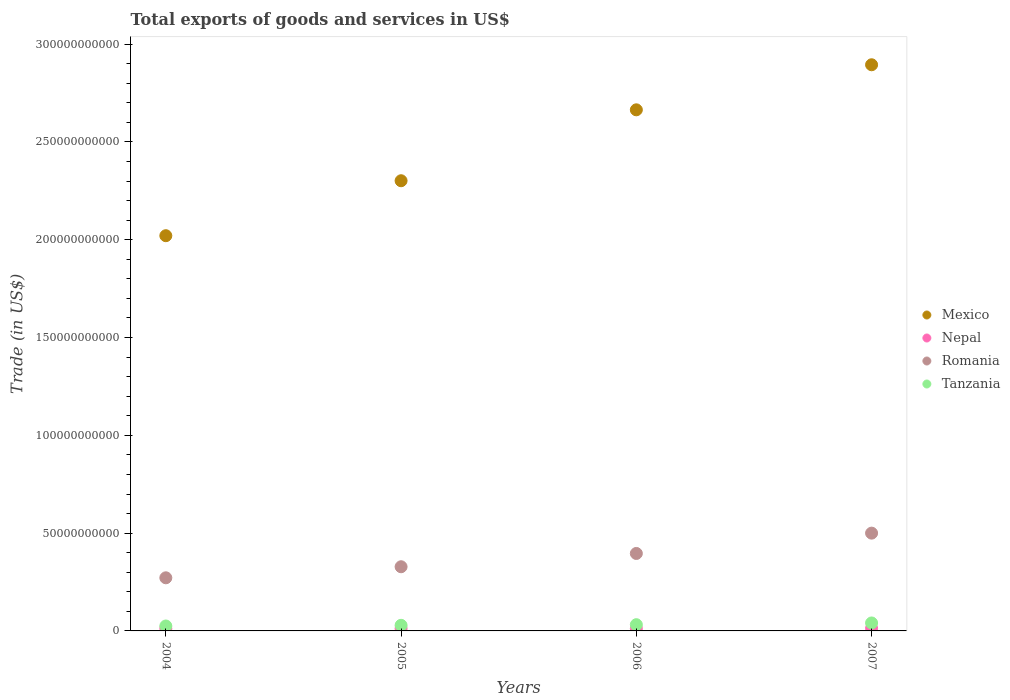How many different coloured dotlines are there?
Make the answer very short. 4. What is the total exports of goods and services in Mexico in 2004?
Your response must be concise. 2.02e+11. Across all years, what is the maximum total exports of goods and services in Tanzania?
Ensure brevity in your answer.  4.07e+09. Across all years, what is the minimum total exports of goods and services in Romania?
Offer a terse response. 2.72e+1. In which year was the total exports of goods and services in Nepal maximum?
Your response must be concise. 2007. In which year was the total exports of goods and services in Romania minimum?
Give a very brief answer. 2004. What is the total total exports of goods and services in Mexico in the graph?
Your answer should be very brief. 9.88e+11. What is the difference between the total exports of goods and services in Nepal in 2004 and that in 2005?
Your answer should be very brief. 2.78e+07. What is the difference between the total exports of goods and services in Nepal in 2006 and the total exports of goods and services in Romania in 2005?
Keep it short and to the point. -3.16e+1. What is the average total exports of goods and services in Nepal per year?
Provide a short and direct response. 1.24e+09. In the year 2006, what is the difference between the total exports of goods and services in Romania and total exports of goods and services in Nepal?
Provide a short and direct response. 3.84e+1. What is the ratio of the total exports of goods and services in Nepal in 2005 to that in 2007?
Give a very brief answer. 0.89. Is the total exports of goods and services in Mexico in 2005 less than that in 2006?
Make the answer very short. Yes. Is the difference between the total exports of goods and services in Romania in 2006 and 2007 greater than the difference between the total exports of goods and services in Nepal in 2006 and 2007?
Your answer should be very brief. No. What is the difference between the highest and the second highest total exports of goods and services in Mexico?
Offer a terse response. 2.30e+1. What is the difference between the highest and the lowest total exports of goods and services in Nepal?
Provide a succinct answer. 1.42e+08. Is the sum of the total exports of goods and services in Nepal in 2004 and 2007 greater than the maximum total exports of goods and services in Tanzania across all years?
Provide a short and direct response. No. Is it the case that in every year, the sum of the total exports of goods and services in Mexico and total exports of goods and services in Romania  is greater than the sum of total exports of goods and services in Nepal and total exports of goods and services in Tanzania?
Offer a terse response. Yes. Is the total exports of goods and services in Mexico strictly greater than the total exports of goods and services in Nepal over the years?
Ensure brevity in your answer.  Yes. Is the total exports of goods and services in Nepal strictly less than the total exports of goods and services in Tanzania over the years?
Provide a succinct answer. Yes. How many dotlines are there?
Keep it short and to the point. 4. Does the graph contain grids?
Your response must be concise. No. What is the title of the graph?
Offer a very short reply. Total exports of goods and services in US$. Does "Brazil" appear as one of the legend labels in the graph?
Your answer should be very brief. No. What is the label or title of the X-axis?
Keep it short and to the point. Years. What is the label or title of the Y-axis?
Offer a very short reply. Trade (in US$). What is the Trade (in US$) in Mexico in 2004?
Ensure brevity in your answer.  2.02e+11. What is the Trade (in US$) of Nepal in 2004?
Offer a very short reply. 1.21e+09. What is the Trade (in US$) of Romania in 2004?
Give a very brief answer. 2.72e+1. What is the Trade (in US$) in Tanzania in 2004?
Your answer should be compact. 2.52e+09. What is the Trade (in US$) of Mexico in 2005?
Make the answer very short. 2.30e+11. What is the Trade (in US$) in Nepal in 2005?
Ensure brevity in your answer.  1.19e+09. What is the Trade (in US$) of Romania in 2005?
Your response must be concise. 3.28e+1. What is the Trade (in US$) of Tanzania in 2005?
Offer a terse response. 2.86e+09. What is the Trade (in US$) in Mexico in 2006?
Your response must be concise. 2.66e+11. What is the Trade (in US$) in Nepal in 2006?
Your answer should be very brief. 1.22e+09. What is the Trade (in US$) in Romania in 2006?
Your answer should be compact. 3.96e+1. What is the Trade (in US$) in Tanzania in 2006?
Your response must be concise. 3.18e+09. What is the Trade (in US$) of Mexico in 2007?
Your answer should be very brief. 2.89e+11. What is the Trade (in US$) of Nepal in 2007?
Make the answer very short. 1.33e+09. What is the Trade (in US$) of Romania in 2007?
Give a very brief answer. 5.00e+1. What is the Trade (in US$) in Tanzania in 2007?
Offer a terse response. 4.07e+09. Across all years, what is the maximum Trade (in US$) in Mexico?
Provide a succinct answer. 2.89e+11. Across all years, what is the maximum Trade (in US$) of Nepal?
Provide a succinct answer. 1.33e+09. Across all years, what is the maximum Trade (in US$) in Romania?
Make the answer very short. 5.00e+1. Across all years, what is the maximum Trade (in US$) in Tanzania?
Give a very brief answer. 4.07e+09. Across all years, what is the minimum Trade (in US$) in Mexico?
Provide a succinct answer. 2.02e+11. Across all years, what is the minimum Trade (in US$) in Nepal?
Provide a succinct answer. 1.19e+09. Across all years, what is the minimum Trade (in US$) of Romania?
Your answer should be compact. 2.72e+1. Across all years, what is the minimum Trade (in US$) of Tanzania?
Your answer should be very brief. 2.52e+09. What is the total Trade (in US$) in Mexico in the graph?
Provide a succinct answer. 9.88e+11. What is the total Trade (in US$) in Nepal in the graph?
Provide a short and direct response. 4.94e+09. What is the total Trade (in US$) of Romania in the graph?
Offer a very short reply. 1.50e+11. What is the total Trade (in US$) in Tanzania in the graph?
Provide a succinct answer. 1.26e+1. What is the difference between the Trade (in US$) of Mexico in 2004 and that in 2005?
Give a very brief answer. -2.81e+1. What is the difference between the Trade (in US$) of Nepal in 2004 and that in 2005?
Offer a terse response. 2.78e+07. What is the difference between the Trade (in US$) of Romania in 2004 and that in 2005?
Offer a very short reply. -5.65e+09. What is the difference between the Trade (in US$) in Tanzania in 2004 and that in 2005?
Offer a terse response. -3.43e+08. What is the difference between the Trade (in US$) in Mexico in 2004 and that in 2006?
Offer a terse response. -6.44e+1. What is the difference between the Trade (in US$) of Nepal in 2004 and that in 2006?
Your answer should be very brief. -2.58e+06. What is the difference between the Trade (in US$) of Romania in 2004 and that in 2006?
Give a very brief answer. -1.24e+1. What is the difference between the Trade (in US$) of Tanzania in 2004 and that in 2006?
Provide a succinct answer. -6.62e+08. What is the difference between the Trade (in US$) of Mexico in 2004 and that in 2007?
Make the answer very short. -8.74e+1. What is the difference between the Trade (in US$) of Nepal in 2004 and that in 2007?
Your response must be concise. -1.14e+08. What is the difference between the Trade (in US$) in Romania in 2004 and that in 2007?
Your answer should be very brief. -2.28e+1. What is the difference between the Trade (in US$) of Tanzania in 2004 and that in 2007?
Your answer should be very brief. -1.55e+09. What is the difference between the Trade (in US$) of Mexico in 2005 and that in 2006?
Keep it short and to the point. -3.63e+1. What is the difference between the Trade (in US$) of Nepal in 2005 and that in 2006?
Make the answer very short. -3.04e+07. What is the difference between the Trade (in US$) of Romania in 2005 and that in 2006?
Your answer should be compact. -6.80e+09. What is the difference between the Trade (in US$) of Tanzania in 2005 and that in 2006?
Your answer should be compact. -3.19e+08. What is the difference between the Trade (in US$) in Mexico in 2005 and that in 2007?
Your answer should be very brief. -5.93e+1. What is the difference between the Trade (in US$) of Nepal in 2005 and that in 2007?
Your answer should be very brief. -1.42e+08. What is the difference between the Trade (in US$) in Romania in 2005 and that in 2007?
Give a very brief answer. -1.72e+1. What is the difference between the Trade (in US$) of Tanzania in 2005 and that in 2007?
Provide a short and direct response. -1.20e+09. What is the difference between the Trade (in US$) of Mexico in 2006 and that in 2007?
Your answer should be very brief. -2.30e+1. What is the difference between the Trade (in US$) of Nepal in 2006 and that in 2007?
Ensure brevity in your answer.  -1.11e+08. What is the difference between the Trade (in US$) in Romania in 2006 and that in 2007?
Offer a very short reply. -1.04e+1. What is the difference between the Trade (in US$) of Tanzania in 2006 and that in 2007?
Provide a succinct answer. -8.85e+08. What is the difference between the Trade (in US$) in Mexico in 2004 and the Trade (in US$) in Nepal in 2005?
Keep it short and to the point. 2.01e+11. What is the difference between the Trade (in US$) in Mexico in 2004 and the Trade (in US$) in Romania in 2005?
Make the answer very short. 1.69e+11. What is the difference between the Trade (in US$) of Mexico in 2004 and the Trade (in US$) of Tanzania in 2005?
Your answer should be compact. 1.99e+11. What is the difference between the Trade (in US$) of Nepal in 2004 and the Trade (in US$) of Romania in 2005?
Give a very brief answer. -3.16e+1. What is the difference between the Trade (in US$) of Nepal in 2004 and the Trade (in US$) of Tanzania in 2005?
Ensure brevity in your answer.  -1.65e+09. What is the difference between the Trade (in US$) in Romania in 2004 and the Trade (in US$) in Tanzania in 2005?
Offer a very short reply. 2.43e+1. What is the difference between the Trade (in US$) in Mexico in 2004 and the Trade (in US$) in Nepal in 2006?
Ensure brevity in your answer.  2.01e+11. What is the difference between the Trade (in US$) in Mexico in 2004 and the Trade (in US$) in Romania in 2006?
Your answer should be very brief. 1.62e+11. What is the difference between the Trade (in US$) of Mexico in 2004 and the Trade (in US$) of Tanzania in 2006?
Keep it short and to the point. 1.99e+11. What is the difference between the Trade (in US$) of Nepal in 2004 and the Trade (in US$) of Romania in 2006?
Offer a terse response. -3.84e+1. What is the difference between the Trade (in US$) of Nepal in 2004 and the Trade (in US$) of Tanzania in 2006?
Keep it short and to the point. -1.97e+09. What is the difference between the Trade (in US$) of Romania in 2004 and the Trade (in US$) of Tanzania in 2006?
Your response must be concise. 2.40e+1. What is the difference between the Trade (in US$) of Mexico in 2004 and the Trade (in US$) of Nepal in 2007?
Ensure brevity in your answer.  2.01e+11. What is the difference between the Trade (in US$) of Mexico in 2004 and the Trade (in US$) of Romania in 2007?
Provide a succinct answer. 1.52e+11. What is the difference between the Trade (in US$) in Mexico in 2004 and the Trade (in US$) in Tanzania in 2007?
Give a very brief answer. 1.98e+11. What is the difference between the Trade (in US$) in Nepal in 2004 and the Trade (in US$) in Romania in 2007?
Your response must be concise. -4.88e+1. What is the difference between the Trade (in US$) in Nepal in 2004 and the Trade (in US$) in Tanzania in 2007?
Provide a short and direct response. -2.85e+09. What is the difference between the Trade (in US$) in Romania in 2004 and the Trade (in US$) in Tanzania in 2007?
Give a very brief answer. 2.31e+1. What is the difference between the Trade (in US$) in Mexico in 2005 and the Trade (in US$) in Nepal in 2006?
Ensure brevity in your answer.  2.29e+11. What is the difference between the Trade (in US$) in Mexico in 2005 and the Trade (in US$) in Romania in 2006?
Provide a short and direct response. 1.91e+11. What is the difference between the Trade (in US$) in Mexico in 2005 and the Trade (in US$) in Tanzania in 2006?
Keep it short and to the point. 2.27e+11. What is the difference between the Trade (in US$) of Nepal in 2005 and the Trade (in US$) of Romania in 2006?
Your answer should be very brief. -3.84e+1. What is the difference between the Trade (in US$) of Nepal in 2005 and the Trade (in US$) of Tanzania in 2006?
Your response must be concise. -2.00e+09. What is the difference between the Trade (in US$) of Romania in 2005 and the Trade (in US$) of Tanzania in 2006?
Your response must be concise. 2.96e+1. What is the difference between the Trade (in US$) in Mexico in 2005 and the Trade (in US$) in Nepal in 2007?
Provide a short and direct response. 2.29e+11. What is the difference between the Trade (in US$) in Mexico in 2005 and the Trade (in US$) in Romania in 2007?
Ensure brevity in your answer.  1.80e+11. What is the difference between the Trade (in US$) in Mexico in 2005 and the Trade (in US$) in Tanzania in 2007?
Provide a short and direct response. 2.26e+11. What is the difference between the Trade (in US$) in Nepal in 2005 and the Trade (in US$) in Romania in 2007?
Give a very brief answer. -4.88e+1. What is the difference between the Trade (in US$) of Nepal in 2005 and the Trade (in US$) of Tanzania in 2007?
Your answer should be very brief. -2.88e+09. What is the difference between the Trade (in US$) in Romania in 2005 and the Trade (in US$) in Tanzania in 2007?
Ensure brevity in your answer.  2.87e+1. What is the difference between the Trade (in US$) in Mexico in 2006 and the Trade (in US$) in Nepal in 2007?
Offer a very short reply. 2.65e+11. What is the difference between the Trade (in US$) of Mexico in 2006 and the Trade (in US$) of Romania in 2007?
Your answer should be very brief. 2.16e+11. What is the difference between the Trade (in US$) in Mexico in 2006 and the Trade (in US$) in Tanzania in 2007?
Offer a terse response. 2.62e+11. What is the difference between the Trade (in US$) in Nepal in 2006 and the Trade (in US$) in Romania in 2007?
Offer a very short reply. -4.88e+1. What is the difference between the Trade (in US$) in Nepal in 2006 and the Trade (in US$) in Tanzania in 2007?
Give a very brief answer. -2.85e+09. What is the difference between the Trade (in US$) in Romania in 2006 and the Trade (in US$) in Tanzania in 2007?
Provide a short and direct response. 3.55e+1. What is the average Trade (in US$) in Mexico per year?
Your response must be concise. 2.47e+11. What is the average Trade (in US$) in Nepal per year?
Give a very brief answer. 1.24e+09. What is the average Trade (in US$) in Romania per year?
Provide a succinct answer. 3.74e+1. What is the average Trade (in US$) in Tanzania per year?
Ensure brevity in your answer.  3.16e+09. In the year 2004, what is the difference between the Trade (in US$) in Mexico and Trade (in US$) in Nepal?
Provide a succinct answer. 2.01e+11. In the year 2004, what is the difference between the Trade (in US$) of Mexico and Trade (in US$) of Romania?
Provide a succinct answer. 1.75e+11. In the year 2004, what is the difference between the Trade (in US$) of Mexico and Trade (in US$) of Tanzania?
Your answer should be compact. 2.00e+11. In the year 2004, what is the difference between the Trade (in US$) in Nepal and Trade (in US$) in Romania?
Give a very brief answer. -2.59e+1. In the year 2004, what is the difference between the Trade (in US$) of Nepal and Trade (in US$) of Tanzania?
Provide a short and direct response. -1.31e+09. In the year 2004, what is the difference between the Trade (in US$) of Romania and Trade (in US$) of Tanzania?
Your answer should be compact. 2.46e+1. In the year 2005, what is the difference between the Trade (in US$) in Mexico and Trade (in US$) in Nepal?
Offer a very short reply. 2.29e+11. In the year 2005, what is the difference between the Trade (in US$) in Mexico and Trade (in US$) in Romania?
Provide a short and direct response. 1.97e+11. In the year 2005, what is the difference between the Trade (in US$) in Mexico and Trade (in US$) in Tanzania?
Provide a short and direct response. 2.27e+11. In the year 2005, what is the difference between the Trade (in US$) in Nepal and Trade (in US$) in Romania?
Provide a succinct answer. -3.16e+1. In the year 2005, what is the difference between the Trade (in US$) in Nepal and Trade (in US$) in Tanzania?
Your response must be concise. -1.68e+09. In the year 2005, what is the difference between the Trade (in US$) of Romania and Trade (in US$) of Tanzania?
Offer a terse response. 2.99e+1. In the year 2006, what is the difference between the Trade (in US$) in Mexico and Trade (in US$) in Nepal?
Offer a very short reply. 2.65e+11. In the year 2006, what is the difference between the Trade (in US$) in Mexico and Trade (in US$) in Romania?
Your answer should be compact. 2.27e+11. In the year 2006, what is the difference between the Trade (in US$) of Mexico and Trade (in US$) of Tanzania?
Your answer should be very brief. 2.63e+11. In the year 2006, what is the difference between the Trade (in US$) in Nepal and Trade (in US$) in Romania?
Offer a very short reply. -3.84e+1. In the year 2006, what is the difference between the Trade (in US$) in Nepal and Trade (in US$) in Tanzania?
Keep it short and to the point. -1.97e+09. In the year 2006, what is the difference between the Trade (in US$) in Romania and Trade (in US$) in Tanzania?
Give a very brief answer. 3.64e+1. In the year 2007, what is the difference between the Trade (in US$) of Mexico and Trade (in US$) of Nepal?
Ensure brevity in your answer.  2.88e+11. In the year 2007, what is the difference between the Trade (in US$) in Mexico and Trade (in US$) in Romania?
Keep it short and to the point. 2.39e+11. In the year 2007, what is the difference between the Trade (in US$) of Mexico and Trade (in US$) of Tanzania?
Give a very brief answer. 2.85e+11. In the year 2007, what is the difference between the Trade (in US$) of Nepal and Trade (in US$) of Romania?
Your answer should be very brief. -4.87e+1. In the year 2007, what is the difference between the Trade (in US$) of Nepal and Trade (in US$) of Tanzania?
Your response must be concise. -2.74e+09. In the year 2007, what is the difference between the Trade (in US$) of Romania and Trade (in US$) of Tanzania?
Ensure brevity in your answer.  4.59e+1. What is the ratio of the Trade (in US$) of Mexico in 2004 to that in 2005?
Ensure brevity in your answer.  0.88. What is the ratio of the Trade (in US$) of Nepal in 2004 to that in 2005?
Keep it short and to the point. 1.02. What is the ratio of the Trade (in US$) of Romania in 2004 to that in 2005?
Give a very brief answer. 0.83. What is the ratio of the Trade (in US$) of Tanzania in 2004 to that in 2005?
Your answer should be very brief. 0.88. What is the ratio of the Trade (in US$) in Mexico in 2004 to that in 2006?
Provide a succinct answer. 0.76. What is the ratio of the Trade (in US$) in Nepal in 2004 to that in 2006?
Offer a terse response. 1. What is the ratio of the Trade (in US$) of Romania in 2004 to that in 2006?
Your answer should be compact. 0.69. What is the ratio of the Trade (in US$) of Tanzania in 2004 to that in 2006?
Your answer should be compact. 0.79. What is the ratio of the Trade (in US$) of Mexico in 2004 to that in 2007?
Your answer should be very brief. 0.7. What is the ratio of the Trade (in US$) in Nepal in 2004 to that in 2007?
Offer a terse response. 0.91. What is the ratio of the Trade (in US$) of Romania in 2004 to that in 2007?
Your answer should be very brief. 0.54. What is the ratio of the Trade (in US$) of Tanzania in 2004 to that in 2007?
Offer a terse response. 0.62. What is the ratio of the Trade (in US$) of Mexico in 2005 to that in 2006?
Keep it short and to the point. 0.86. What is the ratio of the Trade (in US$) of Nepal in 2005 to that in 2006?
Your answer should be very brief. 0.97. What is the ratio of the Trade (in US$) in Romania in 2005 to that in 2006?
Give a very brief answer. 0.83. What is the ratio of the Trade (in US$) in Tanzania in 2005 to that in 2006?
Ensure brevity in your answer.  0.9. What is the ratio of the Trade (in US$) in Mexico in 2005 to that in 2007?
Ensure brevity in your answer.  0.8. What is the ratio of the Trade (in US$) of Nepal in 2005 to that in 2007?
Give a very brief answer. 0.89. What is the ratio of the Trade (in US$) in Romania in 2005 to that in 2007?
Keep it short and to the point. 0.66. What is the ratio of the Trade (in US$) in Tanzania in 2005 to that in 2007?
Offer a very short reply. 0.7. What is the ratio of the Trade (in US$) of Mexico in 2006 to that in 2007?
Your answer should be compact. 0.92. What is the ratio of the Trade (in US$) of Nepal in 2006 to that in 2007?
Your answer should be very brief. 0.92. What is the ratio of the Trade (in US$) of Romania in 2006 to that in 2007?
Your response must be concise. 0.79. What is the ratio of the Trade (in US$) of Tanzania in 2006 to that in 2007?
Give a very brief answer. 0.78. What is the difference between the highest and the second highest Trade (in US$) of Mexico?
Keep it short and to the point. 2.30e+1. What is the difference between the highest and the second highest Trade (in US$) of Nepal?
Your answer should be compact. 1.11e+08. What is the difference between the highest and the second highest Trade (in US$) of Romania?
Provide a short and direct response. 1.04e+1. What is the difference between the highest and the second highest Trade (in US$) in Tanzania?
Provide a short and direct response. 8.85e+08. What is the difference between the highest and the lowest Trade (in US$) of Mexico?
Give a very brief answer. 8.74e+1. What is the difference between the highest and the lowest Trade (in US$) in Nepal?
Make the answer very short. 1.42e+08. What is the difference between the highest and the lowest Trade (in US$) of Romania?
Give a very brief answer. 2.28e+1. What is the difference between the highest and the lowest Trade (in US$) of Tanzania?
Offer a terse response. 1.55e+09. 